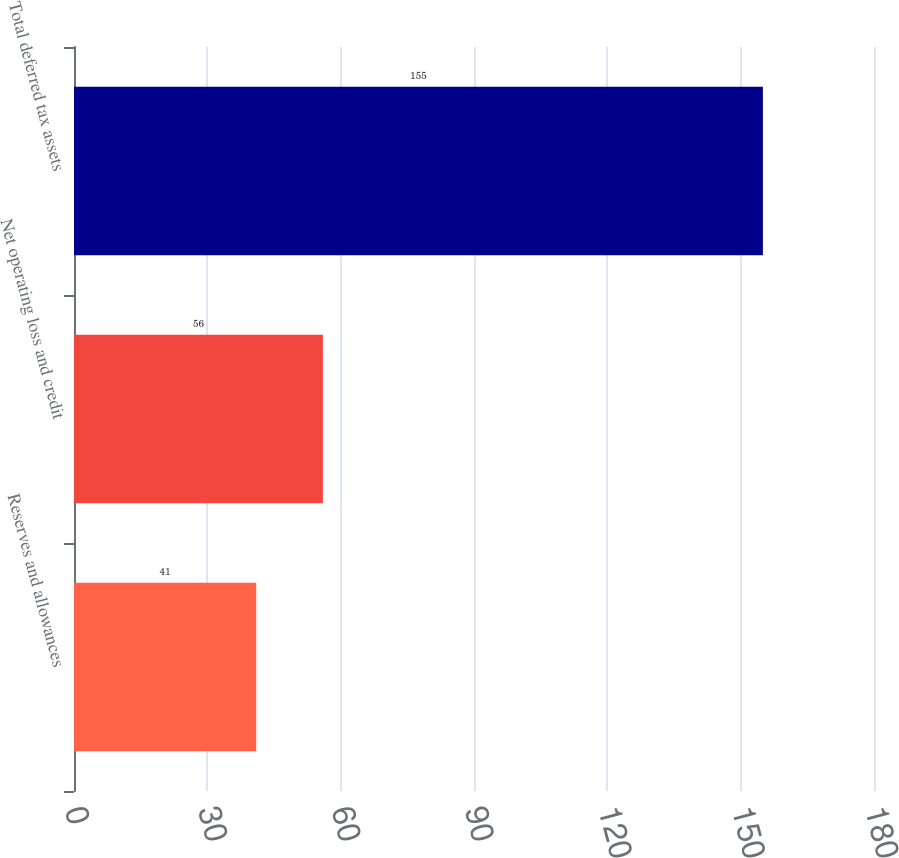Convert chart. <chart><loc_0><loc_0><loc_500><loc_500><bar_chart><fcel>Reserves and allowances<fcel>Net operating loss and credit<fcel>Total deferred tax assets<nl><fcel>41<fcel>56<fcel>155<nl></chart> 